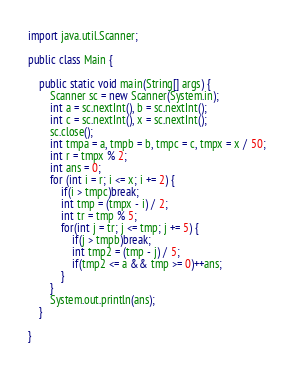<code> <loc_0><loc_0><loc_500><loc_500><_Java_>import java.util.Scanner;

public class Main {

	public static void main(String[] args) {
		Scanner sc = new Scanner(System.in);
		int a = sc.nextInt(), b = sc.nextInt();
		int c = sc.nextInt(), x = sc.nextInt();
		sc.close();
		int tmpa = a, tmpb = b, tmpc = c, tmpx = x / 50;
		int r = tmpx % 2;
		int ans = 0;
		for (int i = r; i <= x; i += 2) {
			if(i > tmpc)break;
			int tmp = (tmpx - i) / 2;
			int tr = tmp % 5;
			for(int j = tr; j <= tmp; j += 5) {
				if(j > tmpb)break;
				int tmp2 = (tmp - j) / 5;
				if(tmp2 <= a && tmp >= 0)++ans;
			}
		}
		System.out.println(ans);
	}

}
</code> 